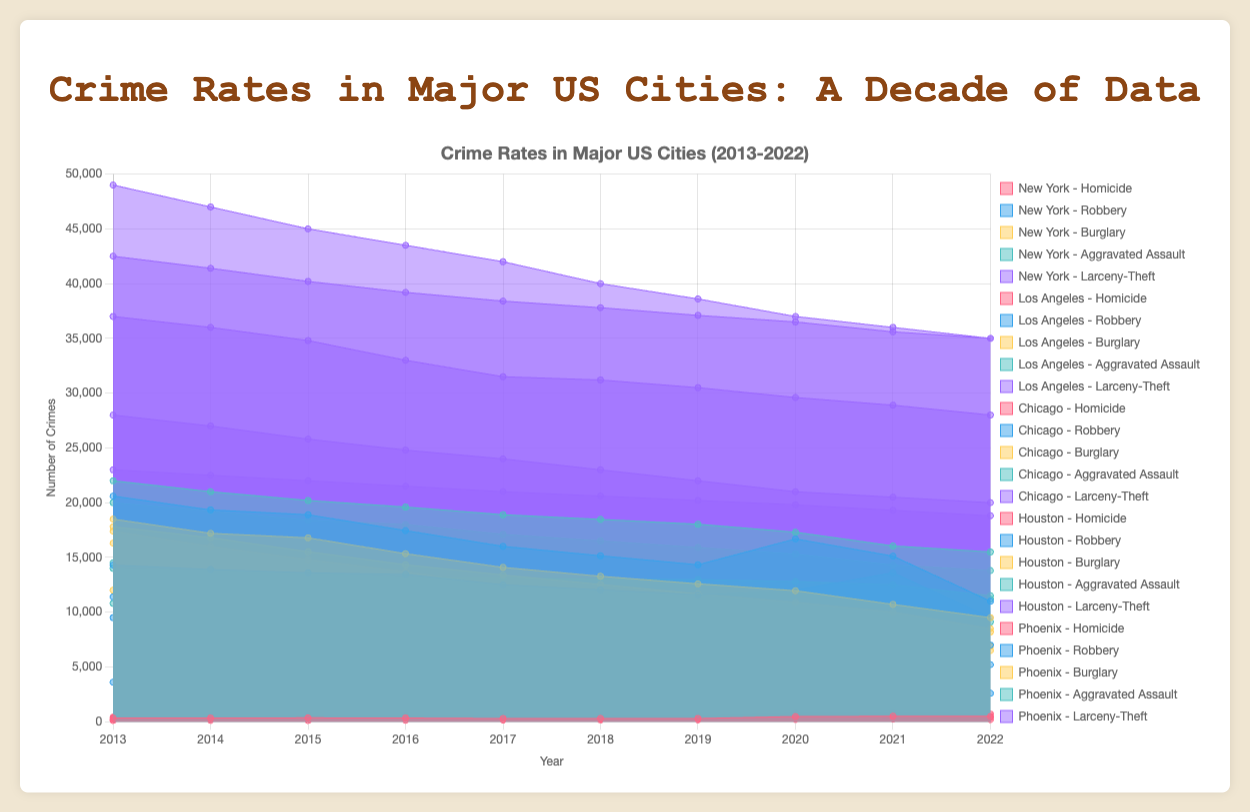What's the title of the chart? The title is displayed at the top of the chart and reads "Crime Rates in Major US Cities (2013-2022)."
Answer: Crime Rates in Major US Cities (2013-2022) Which city had the highest number of homicides in 2020? Looking at the datasets for 2020 in the Homicide category, Chicago has the highest number with 772 homicides.
Answer: Chicago Compare the number of burglaries in Los Angeles and Phoenix for the year 2017. Which city had fewer burglaries? For the year 2017, the number of burglaries is 13,400 in Los Angeles and 9,800 in Phoenix. Phoenix has fewer burglaries.
Answer: Phoenix Which crime type shows the highest number of incidents in New York in 2013? By analyzing the data for New York in 2013, Larceny-Theft has the highest number of incidents at 42,500.
Answer: Larceny-Theft By how much did the number of robberies in Houston decrease from 2013 to 2022? The number of robberies in Houston was 9,500 in 2013 and 5,200 in 2022. The decrease is 9,500 - 5,200 = 4,300.
Answer: 4,300 Which city had the most significant increase in homicide rates from 2019 to 2020? Comparing the increase in homicide rates from 2019 to 2020, New York increased from 292 to 468 (+176), Los Angeles from 281 to 544 (+263), Chicago from 490 to 772 (+282), Houston from 293 to 413 (+120), and Phoenix from 165 to 207 (+42). The most significant increase is in Chicago (+282).
Answer: Chicago What was the average number of aggravated assaults in New York across the decade? Adding the aggravated assaults for New York across the decade (2013-2022): 22,000, 21,000, 20,200, 19,600, 18,900, 18,470, 18,030, 17,300, 16,050, 15,500. The total is 181,050. The average is 181,050 / 10 = 18,105.
Answer: 18,105 How did the number of larceny-theft incidents in Phoenix change from 2013 to 2022? Comparing the number of larceny-theft incidents in Phoenix: in 2013 there were 23,000 and in 2022 there were 18,800. The change is 23,000 - 18,800 = -4,200 (a decrease of 4,200).
Answer: Decreased by 4,200 Which city had the lowest number of robberies in 2018? By looking at the dataset for robberies in 2018, the numbers are: New York (15,150), Los Angeles (12,030), Chicago (9,000), Houston (7,800), and Phoenix (3,700). Phoenix had the lowest number.
Answer: Phoenix 